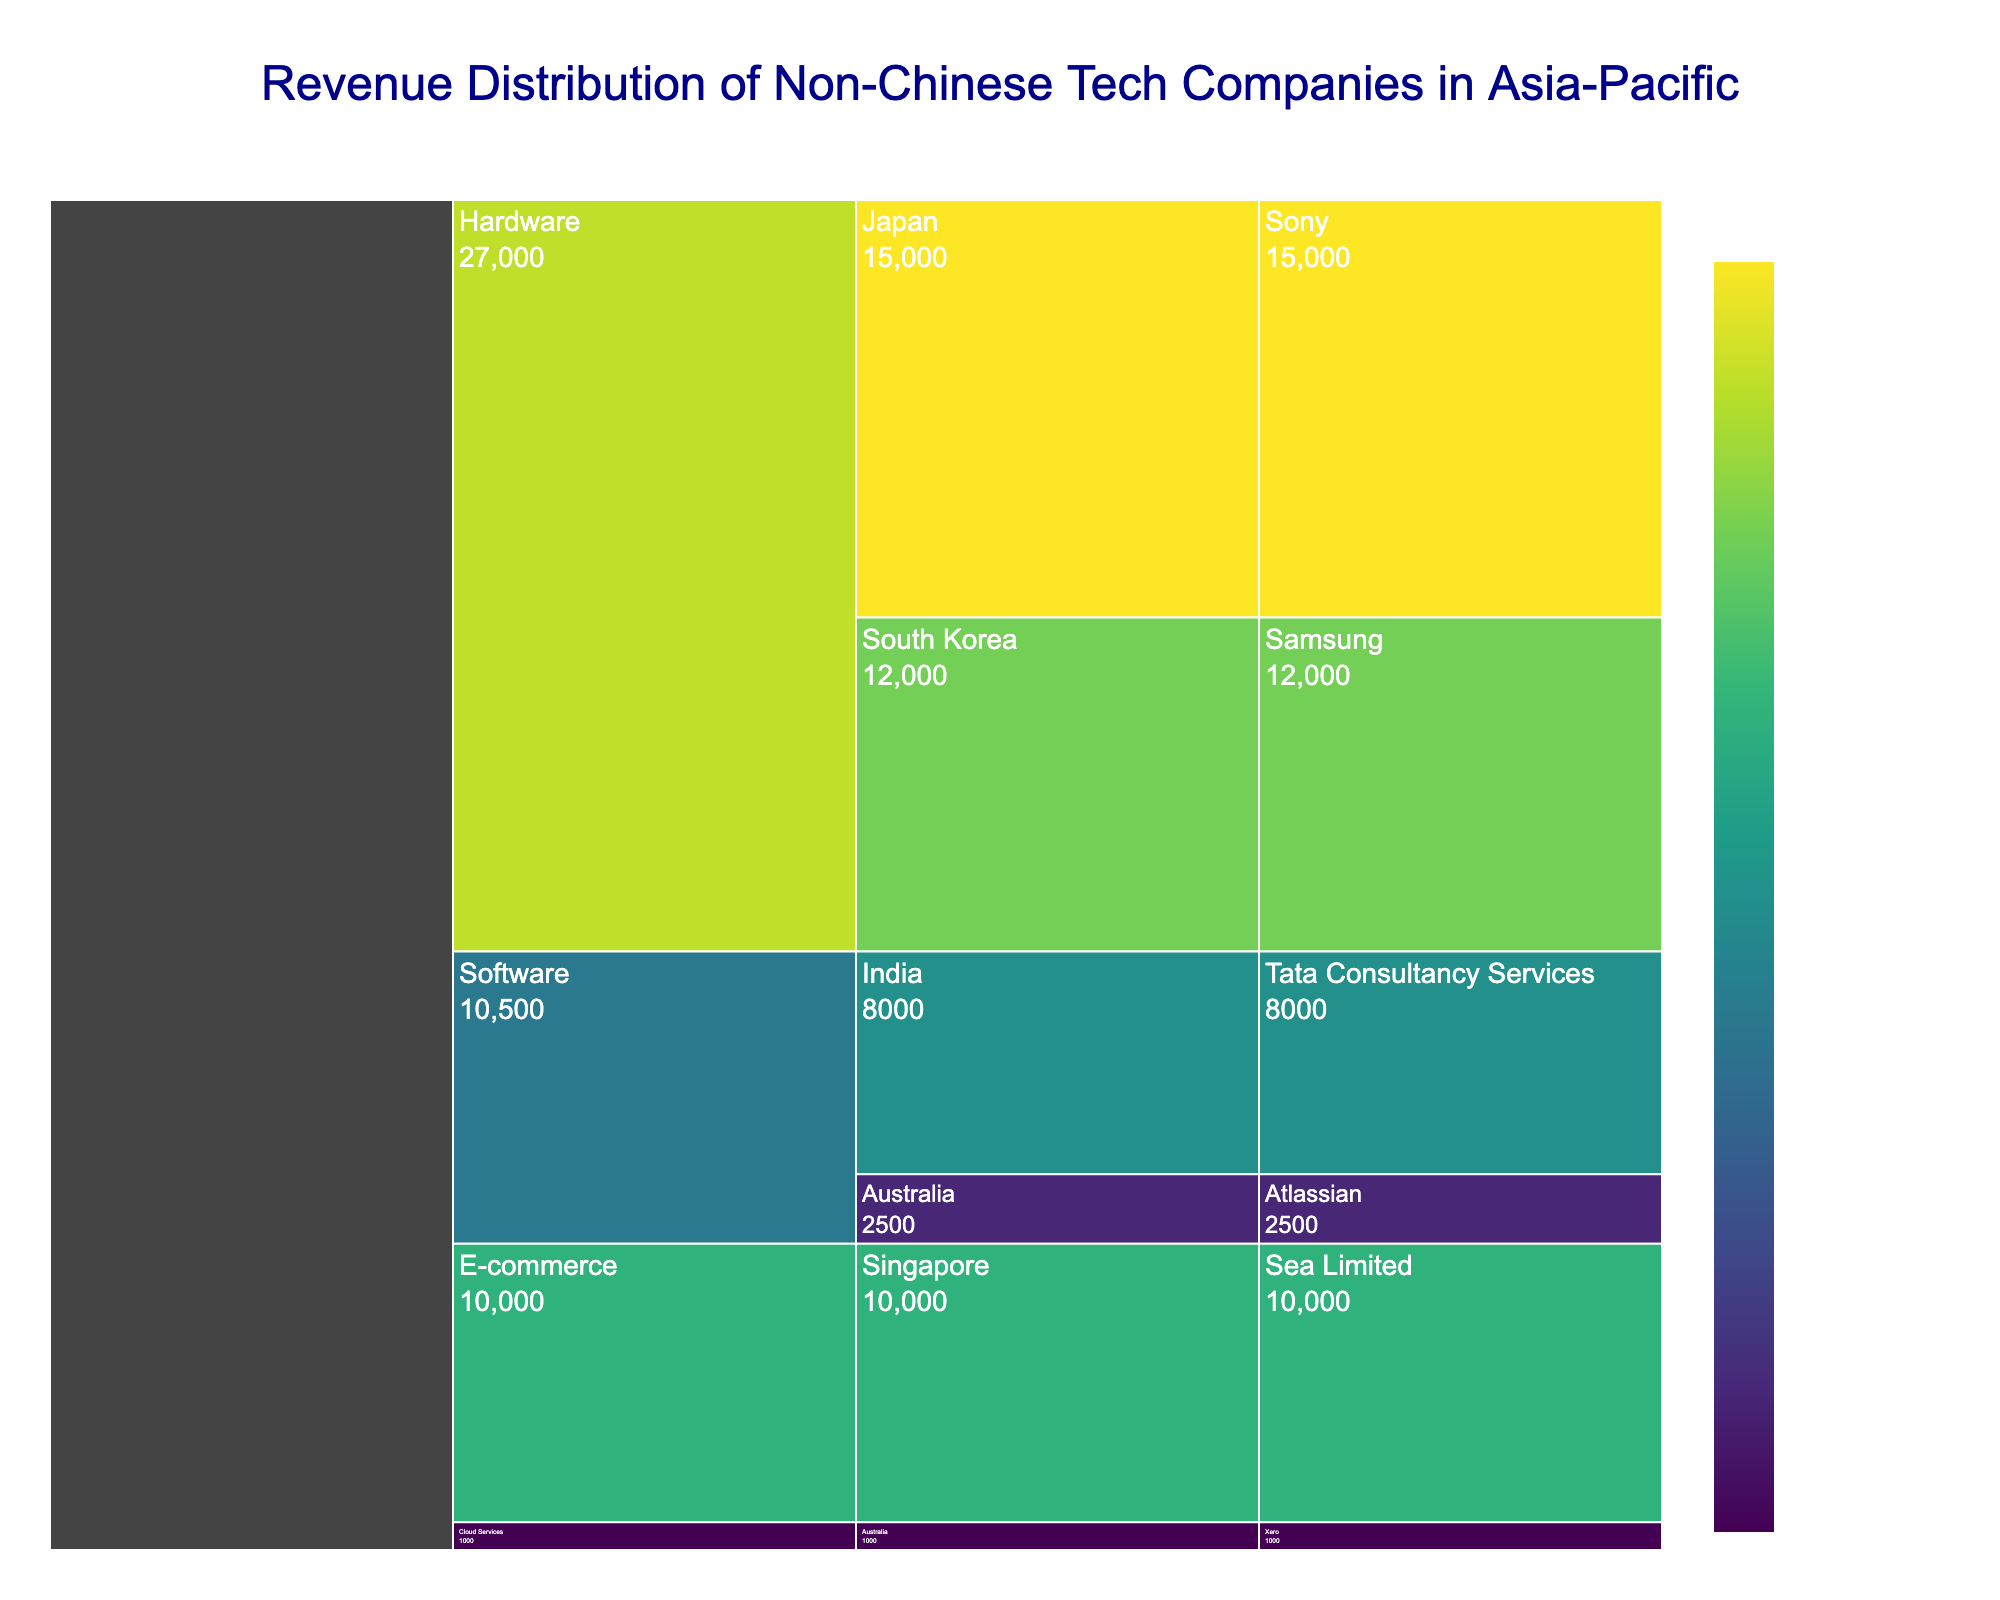What is the total revenue for the Hardware category? Add the revenue for Sony (Japan) and Samsung (South Korea). 15000 + 12000 = 27000
Answer: 27000 million $ In which country is Atlassian located? Refer to the "Software" category and find Atlassian, which is located in Australia.
Answer: Australia What is the title of the plot? The plot title is shown at the top of the chart.
Answer: Revenue Distribution of Non-Chinese Tech Companies in Asia-Pacific What is the total revenue generated by companies in Australia? Add the revenue of Atlassian (2500) and Xero (1000). 2500 + 1000 = 3500
Answer: 3500 million $ What is the average revenue for companies in the Software category? Add the revenue for Tata Consultancy Services (8000) and Atlassian (2500), then divide by 2. (8000 + 2500) / 2 = 5250
Answer: 5250 million $ Which company has the lowest revenue in the chart? Compare all companies' revenue and find the minimum value, which is Xero with 1000.
Answer: Xero Which category has the greater revenue, Hardware or Software? Compare the total revenue of Hardware (27000) and Software (10500). Hardware: 15000 (Sony) + 12000 (Samsung) = 27000. Software: 8000 (Tata Consultancy Services) + 2500 (Atlassian) = 10500. 27000 is greater than 10500.
Answer: Hardware How is the revenue distributed within the E-commerce category? There is only one company, Sea Limited, with revenue of 10000.
Answer: Sea Limited: 10000 million $ Which country has the company with the highest revenue in the Hardware category? Look at the Hardware category and compare the revenues of Sony (Japan) and Samsung (South Korea). Sony (Japan) has the highest revenue with 15000.
Answer: Japan 